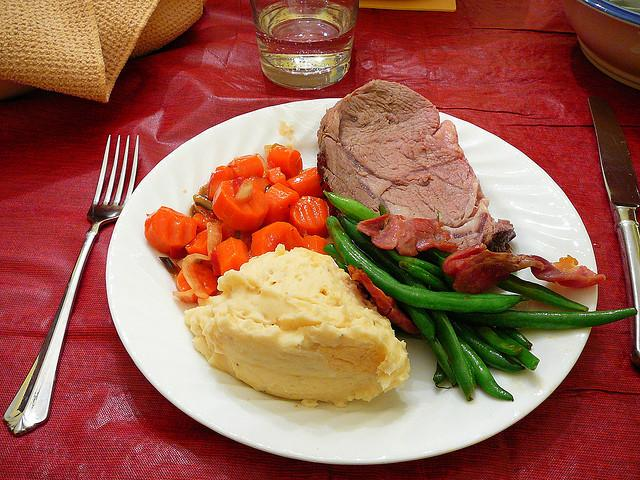What is a healthy item on the plate? Please explain your reasoning. carrot. The carrots on the plate are the healthiest food item on the plate because it is low in fat. 